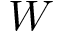Convert formula to latex. <formula><loc_0><loc_0><loc_500><loc_500>W</formula> 